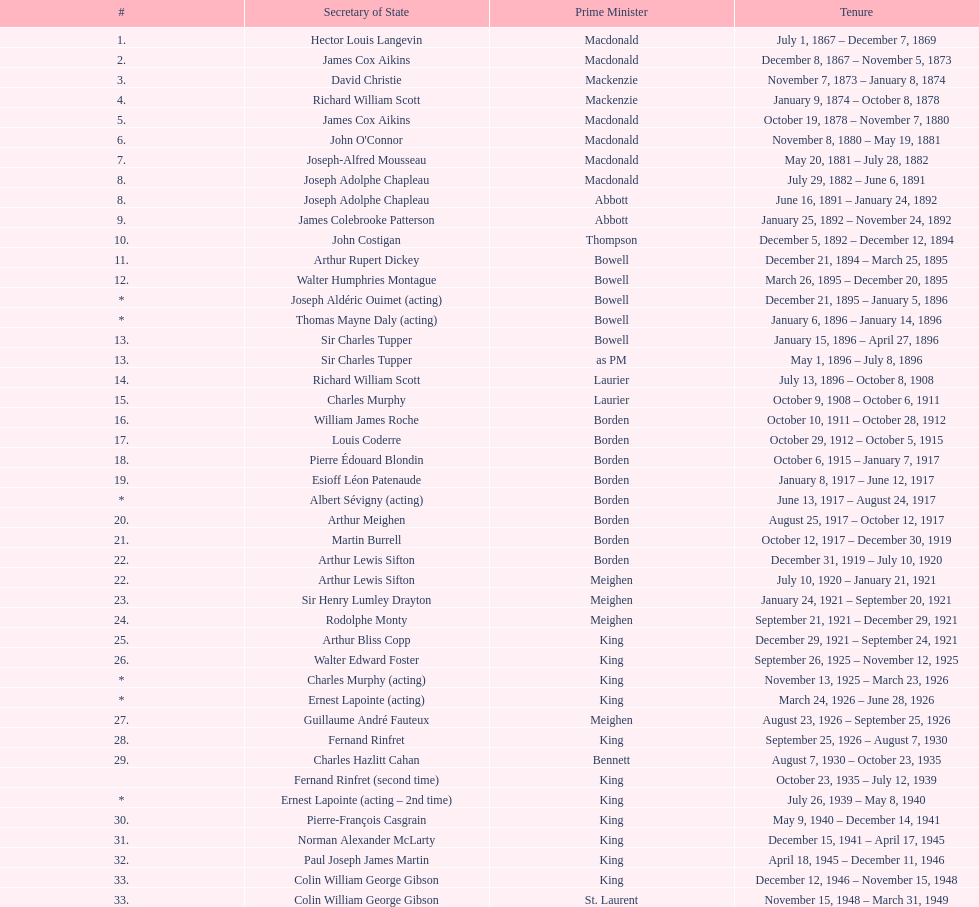What secretary of state was a part of both prime minister laurier's and prime minister king's administrations? Charles Murphy. 